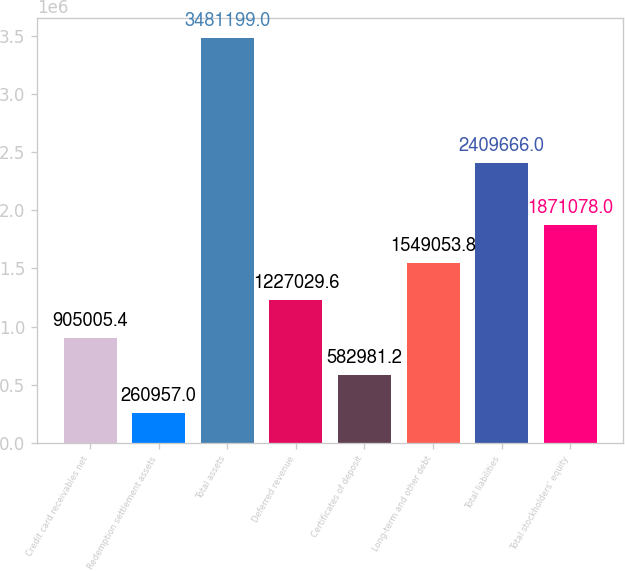Convert chart. <chart><loc_0><loc_0><loc_500><loc_500><bar_chart><fcel>Credit card receivables net<fcel>Redemption settlement assets<fcel>Total assets<fcel>Deferred revenue<fcel>Certificates of deposit<fcel>Long-term and other debt<fcel>Total liabilities<fcel>Total stockholders' equity<nl><fcel>905005<fcel>260957<fcel>3.4812e+06<fcel>1.22703e+06<fcel>582981<fcel>1.54905e+06<fcel>2.40967e+06<fcel>1.87108e+06<nl></chart> 